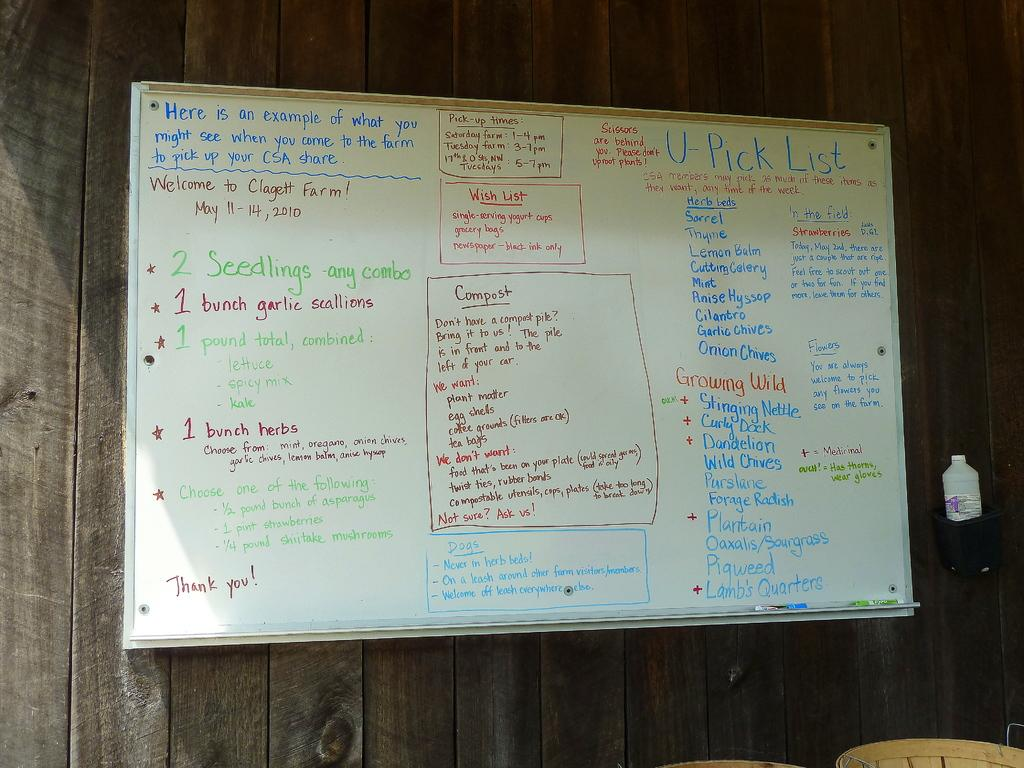<image>
Share a concise interpretation of the image provided. A whiteboard give a list of available produce at a CSA. 